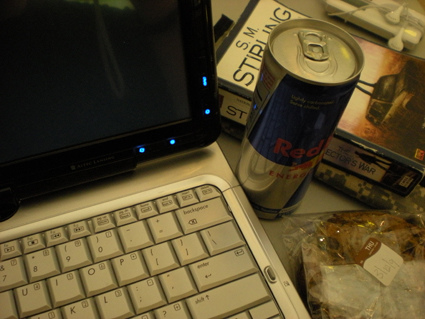<image>What famous cartoon character is on the front of the book? There is no famous cartoon character on the front of the book. What famous cartoon character is on the front of the book? I don't know which famous cartoon character is on the front of the book. It is not recognizable in the image. 